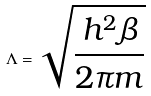<formula> <loc_0><loc_0><loc_500><loc_500>\Lambda = \sqrt { \frac { h ^ { 2 } \beta } { 2 \pi m } }</formula> 